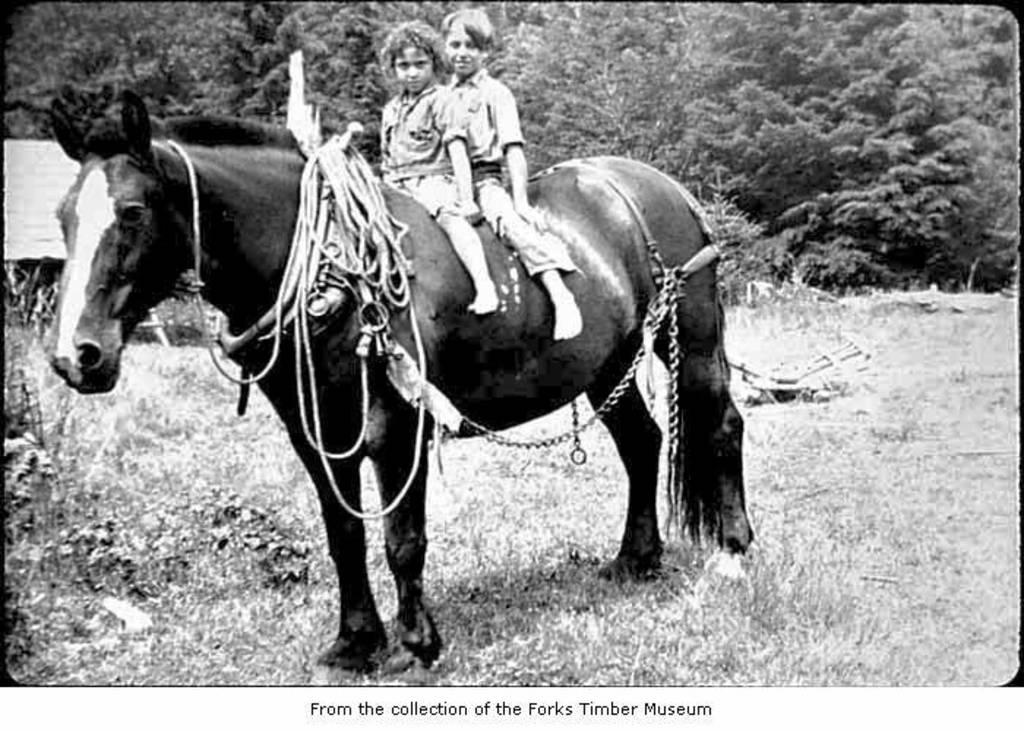How many people are in the image? There are two persons in the image. What are the persons doing in the image? The persons are sitting on a horse. What is attached to the horse in the image? Ropes and chains are tied to the horse. What is the color of the horse in the image? The horse is black in color. What is the horse standing on in the image? The horse is standing on the grass. What can be seen in the background of the image? There are trees visible in the background. Where is the seashore located in the image? There is no seashore present in the image; it features a horse with two persons sitting on it, surrounded by grass and trees. What type of knife is being used by the persons in the image? There is no knife present in the image; the persons are sitting on a horse with ropes and chains attached to it. 